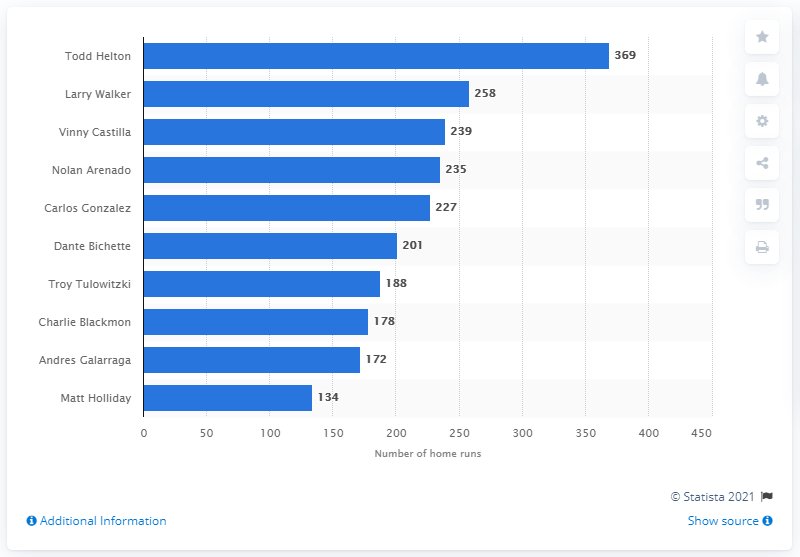List a handful of essential elements in this visual. Todd Helton has hit an impressive 369 home runs to date. The Colorado Rockies franchise has seen many talented hitters over the years, but none have hit more home runs than Todd Helton. 